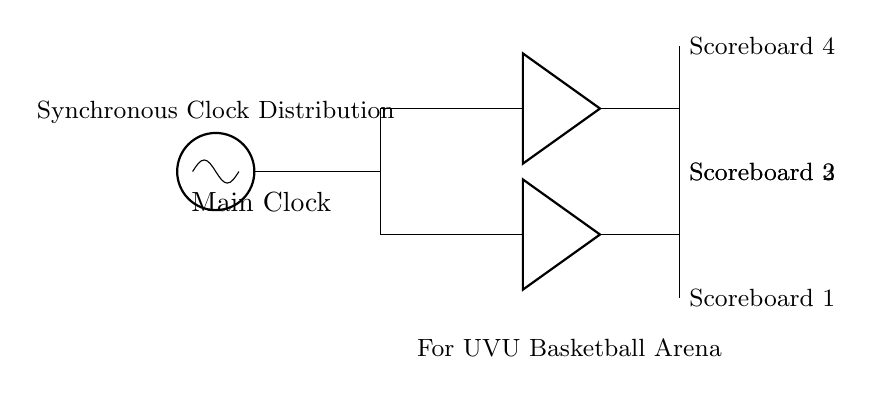What is the main component of the circuit? The main component is the oscillator, shown at the beginning of the diagram. It generates the main clock signal.
Answer: oscillator How many scoreboards are connected to the clock distribution network? There are four scoreboards connected, indicated by the labels on the sides of the buffer outputs.
Answer: four What type of components are used for buffering the clock signal? The components used for buffering are labeled as buffers in the diagram, positioned after the main clock and before the scoreboards.
Answer: buffers What is the function of the buffers in this circuit? The function of the buffers is to strengthen the clock signal from the oscillator before it is distributed to the scoreboards, helping maintain signal integrity.
Answer: strengthen signal Which scoreboard is directly connected to the first buffer? The scoreboard directly connected to the first buffer is Scoreboard 1, which is indicated by the line drawn from the buffer.
Answer: Scoreboard 1 Why is a synchronous clock distribution necessary in this design? A synchronous clock distribution is necessary to ensure that all scoreboards display the same timing information simultaneously, which is crucial for accurate game management.
Answer: accurate timing What is the purpose of the main clock in this circuit? The main clock generates a timing signal that coordinates the operation of all connected components, crucial for synchronizing the scoreboards.
Answer: coordinating operation 